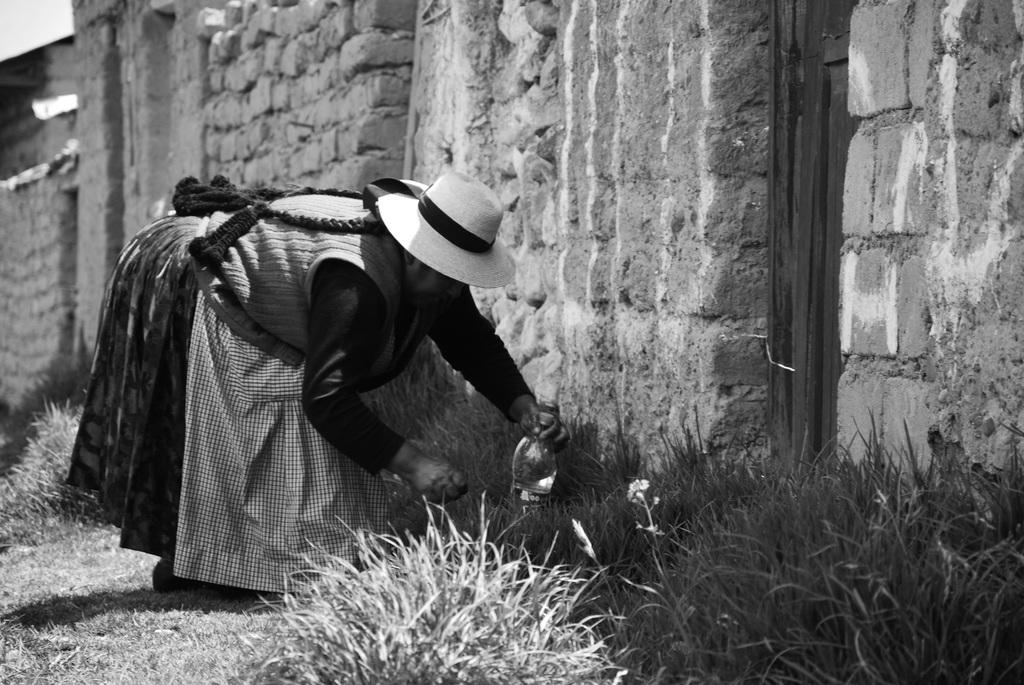What is the color scheme of the image? The image is black and white. Who is present in the image? There is a woman in the image. What is the woman doing in the image? The woman is holding an object and doing some work with it. What type of natural environment is visible in the image? There is a lot of grass in the image. What can be seen behind the grass in the image? There is a wall visible behind the grass. How many oranges are being used by the woman in the image? There are no oranges present in the image. What type of picture is the woman holding in the image? The woman is not holding a picture in the image; she is holding an unspecified object. 